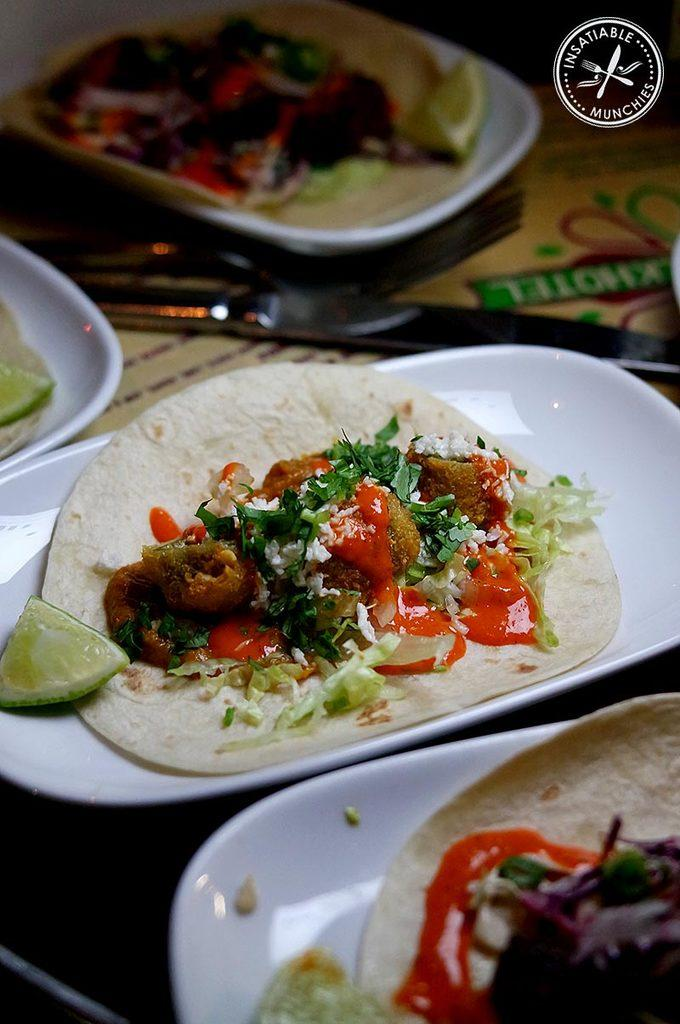What can be seen on the plates in the image? There are food items on plates in the image. What utensil is present in the image? There is a knife in the image. Where is the logo located in the image? The logo is in the top right corner of the image. What type of juice is being served in the image? There is no juice present in the image; it only shows food items on plates and a knife. 